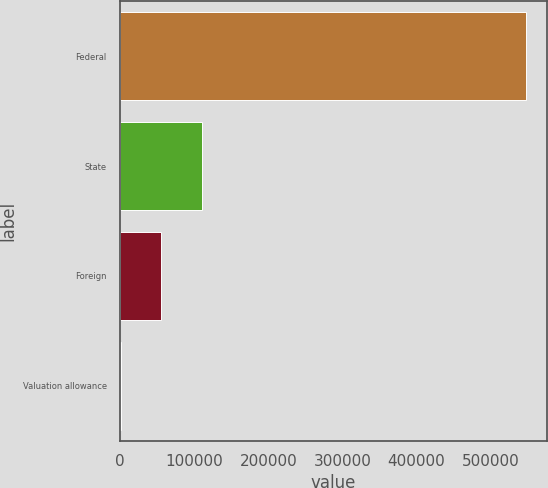Convert chart to OTSL. <chart><loc_0><loc_0><loc_500><loc_500><bar_chart><fcel>Federal<fcel>State<fcel>Foreign<fcel>Valuation allowance<nl><fcel>548018<fcel>110580<fcel>55899.8<fcel>1220<nl></chart> 